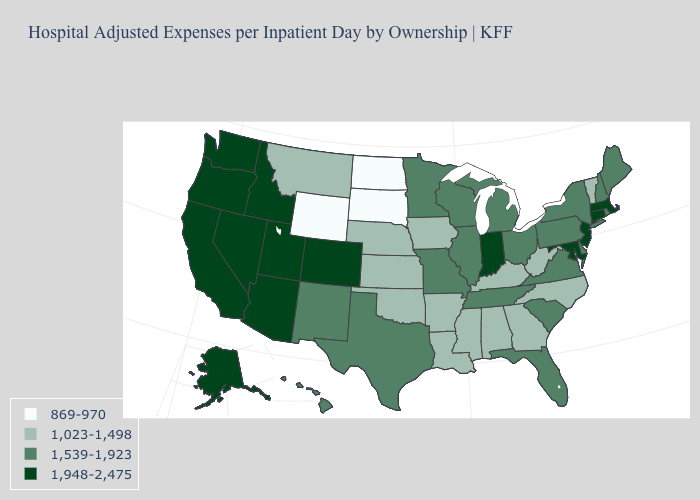Does the first symbol in the legend represent the smallest category?
Write a very short answer. Yes. Which states hav the highest value in the South?
Keep it brief. Maryland. What is the value of New Jersey?
Concise answer only. 1,948-2,475. Name the states that have a value in the range 869-970?
Short answer required. North Dakota, South Dakota, Wyoming. Does the first symbol in the legend represent the smallest category?
Answer briefly. Yes. What is the highest value in states that border Massachusetts?
Answer briefly. 1,948-2,475. Which states have the lowest value in the USA?
Quick response, please. North Dakota, South Dakota, Wyoming. Name the states that have a value in the range 1,539-1,923?
Be succinct. Delaware, Florida, Hawaii, Illinois, Maine, Michigan, Minnesota, Missouri, New Hampshire, New Mexico, New York, Ohio, Pennsylvania, Rhode Island, South Carolina, Tennessee, Texas, Virginia, Wisconsin. Among the states that border Oklahoma , does Colorado have the lowest value?
Write a very short answer. No. Among the states that border Minnesota , does Wisconsin have the highest value?
Concise answer only. Yes. Name the states that have a value in the range 1,539-1,923?
Give a very brief answer. Delaware, Florida, Hawaii, Illinois, Maine, Michigan, Minnesota, Missouri, New Hampshire, New Mexico, New York, Ohio, Pennsylvania, Rhode Island, South Carolina, Tennessee, Texas, Virginia, Wisconsin. Name the states that have a value in the range 1,948-2,475?
Give a very brief answer. Alaska, Arizona, California, Colorado, Connecticut, Idaho, Indiana, Maryland, Massachusetts, Nevada, New Jersey, Oregon, Utah, Washington. Does Massachusetts have the highest value in the USA?
Answer briefly. Yes. 